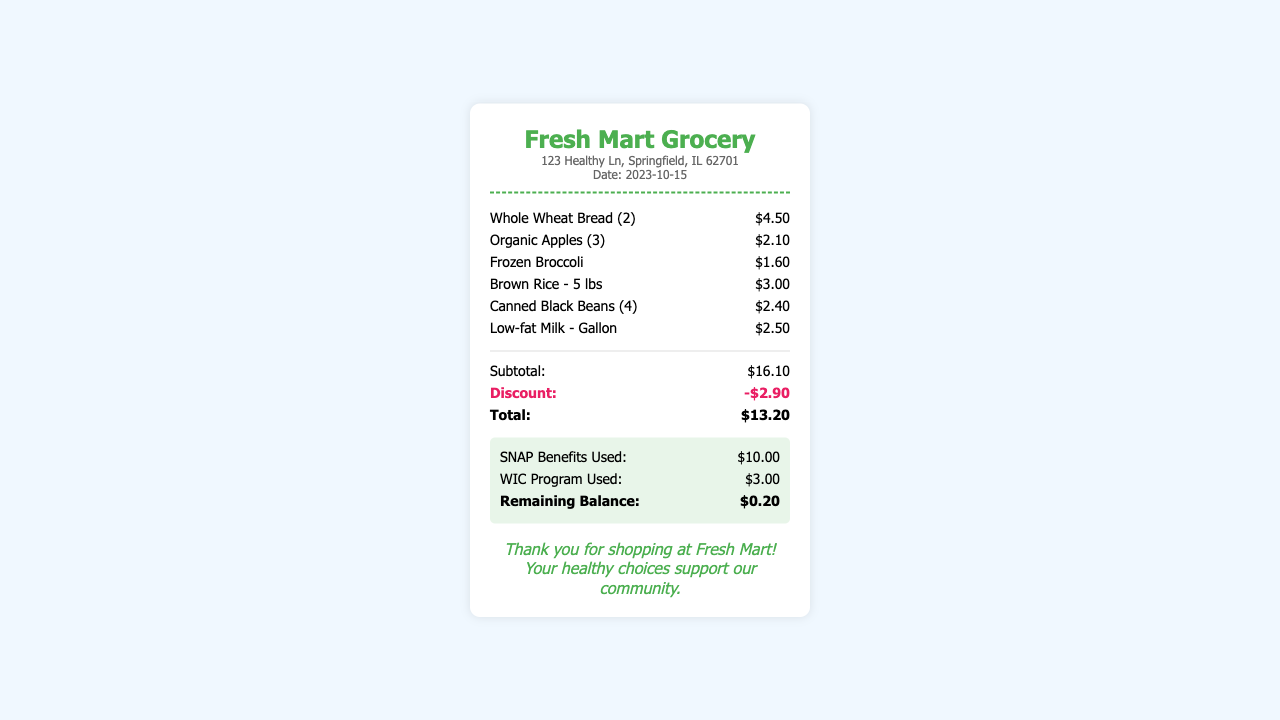What is the store name? The store name is displayed at the top of the receipt.
Answer: Fresh Mart Grocery What is the total amount after discount? The total amount is calculated after applying the discount to the subtotal.
Answer: $13.20 How much was the discount applied? The discount amount is listed separately below the subtotal.
Answer: -$2.90 How many Organic Apples were purchased? The quantity of Organic Apples is indicated in parentheses next to the item name.
Answer: 3 What date was the purchase made? The date is listed on the receipt, providing when the transaction occurred.
Answer: 2023-10-15 What was the subtotal before discounts? The subtotal is shown before any discounts are applied.
Answer: $16.10 How much were the SNAP benefits used? The amount of SNAP benefits used is shown in the incentives section of the receipt.
Answer: $10.00 What is the remaining balance after using benefits? The remaining balance indicates what was left after benefits were applied.
Answer: $0.20 What type of incentives does this receipt show? The receipt lists specific programs that provide financial assistance for groceries.
Answer: SNAP and WIC 